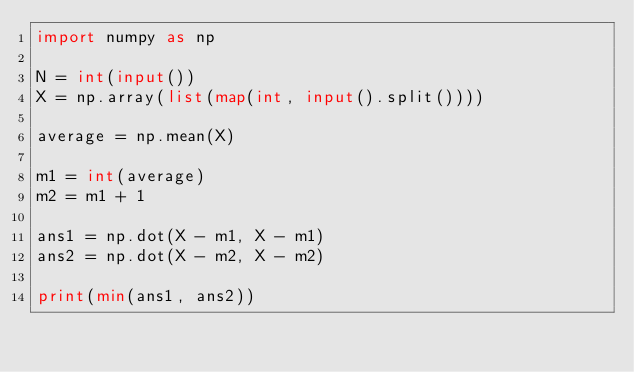Convert code to text. <code><loc_0><loc_0><loc_500><loc_500><_Python_>import numpy as np

N = int(input())
X = np.array(list(map(int, input().split())))

average = np.mean(X)

m1 = int(average)
m2 = m1 + 1

ans1 = np.dot(X - m1, X - m1)
ans2 = np.dot(X - m2, X - m2)

print(min(ans1, ans2))

</code> 